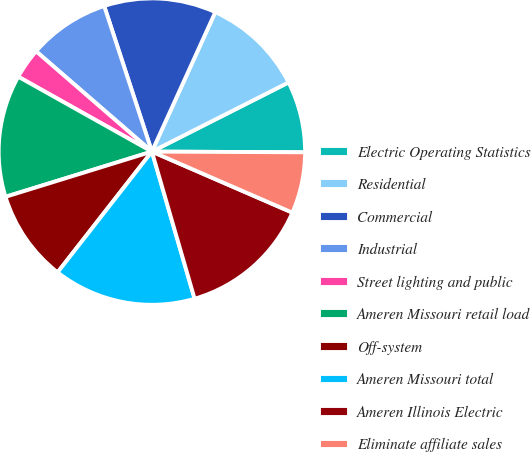Convert chart. <chart><loc_0><loc_0><loc_500><loc_500><pie_chart><fcel>Electric Operating Statistics<fcel>Residential<fcel>Commercial<fcel>Industrial<fcel>Street lighting and public<fcel>Ameren Missouri retail load<fcel>Off-system<fcel>Ameren Missouri total<fcel>Ameren Illinois Electric<fcel>Eliminate affiliate sales<nl><fcel>7.53%<fcel>10.75%<fcel>11.83%<fcel>8.6%<fcel>3.23%<fcel>12.9%<fcel>9.68%<fcel>15.05%<fcel>13.98%<fcel>6.45%<nl></chart> 